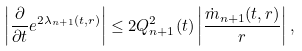Convert formula to latex. <formula><loc_0><loc_0><loc_500><loc_500>\left | \frac { \partial } { \partial t } e ^ { 2 \lambda _ { n + 1 } ( t , r ) } \right | \leq 2 Q _ { n + 1 } ^ { 2 } ( t ) \left | \frac { \dot { m } _ { n + 1 } ( t , r ) } { r } \right | ,</formula> 